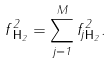<formula> <loc_0><loc_0><loc_500><loc_500>\| f \| _ { { \mathbf H } _ { 2 } } ^ { 2 } = \sum _ { j = 1 } ^ { M } \| f _ { j } \| _ { { \mathbf H } _ { 2 } } ^ { 2 } .</formula> 